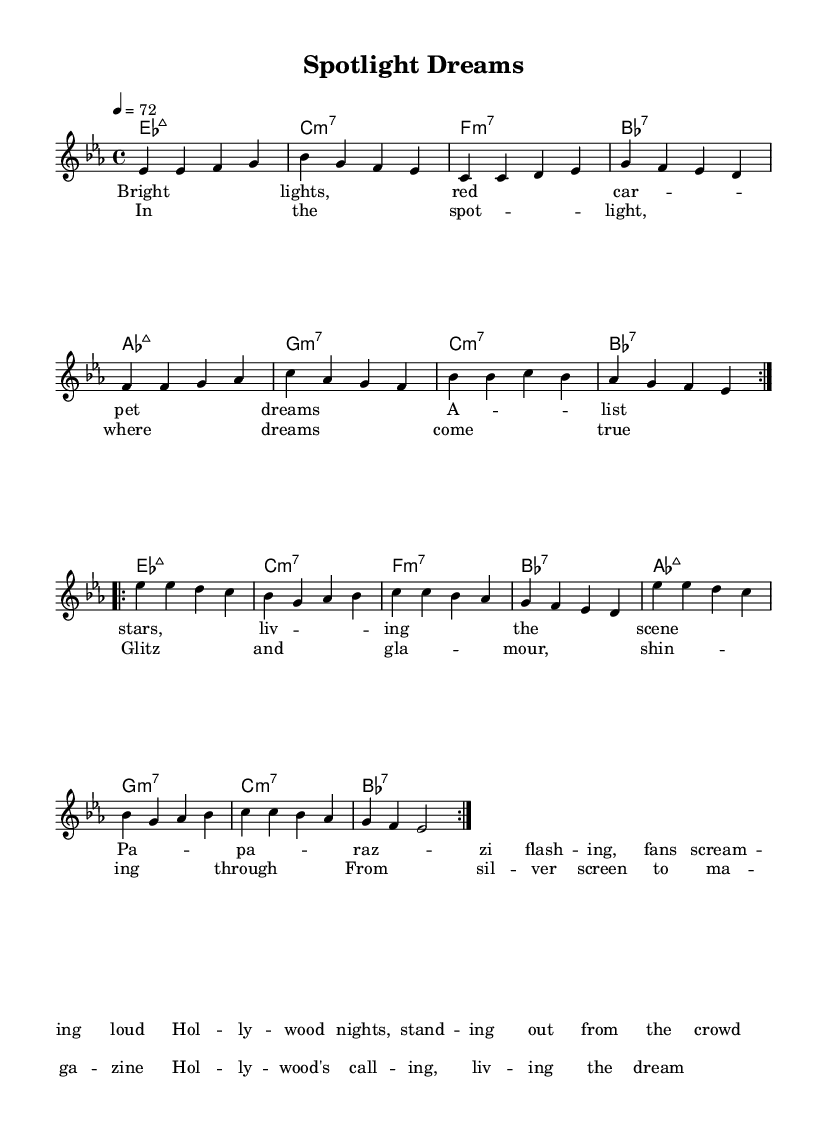What is the key signature of this music? The key signature is E flat major, which includes three flats (B flat, E flat, and A flat).
Answer: E flat major What is the time signature of this music? The time signature appears at the beginning of the piece and shows that there are four beats in each measure, which indicates a common time signature.
Answer: 4/4 What is the tempo marking given for this music? The tempo marking is indicated as a quarter note = 72 beats per minute, which suggests a moderate tempo.
Answer: 72 What type of chords are predominantly used in the harmony section? Upon examining the harmonic structure, the chords present include major seventh chords and minor seventh chords, characteristic of a smooth R&B style.
Answer: Major seventh and minor seventh In the chorus lyrics, what phrase indicates the theme of aspiration? The phrase "where dreams come true" highlights the aspirational aspect associated with Hollywood, emphasizing achieving one's dreams.
Answer: where dreams come true How many times is the melody repeated before the break? The melody is marked to repeat for two volta, meaning it goes through the section twice before moving on, which is common in songwriting to reinforce the theme.
Answer: Twice 